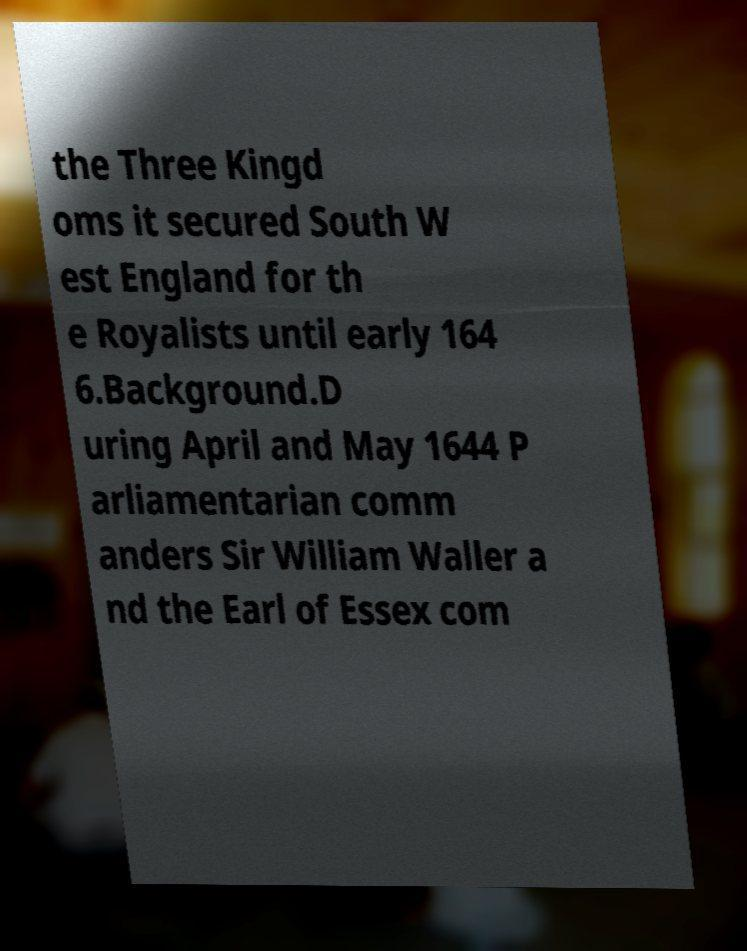Can you accurately transcribe the text from the provided image for me? the Three Kingd oms it secured South W est England for th e Royalists until early 164 6.Background.D uring April and May 1644 P arliamentarian comm anders Sir William Waller a nd the Earl of Essex com 